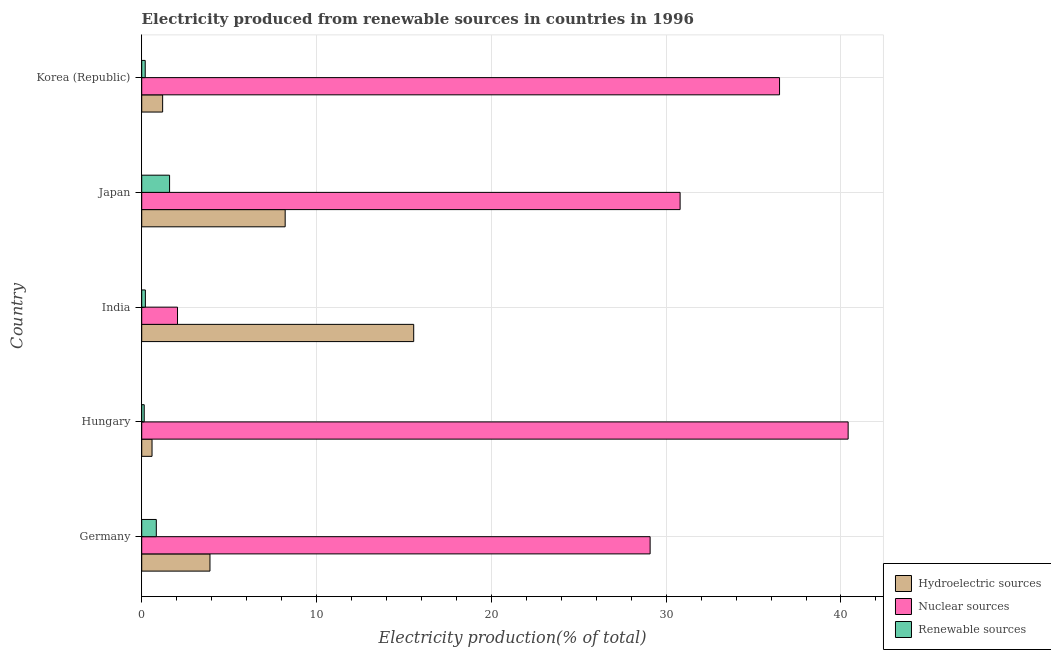How many different coloured bars are there?
Provide a succinct answer. 3. Are the number of bars per tick equal to the number of legend labels?
Keep it short and to the point. Yes. Are the number of bars on each tick of the Y-axis equal?
Your response must be concise. Yes. What is the label of the 1st group of bars from the top?
Provide a short and direct response. Korea (Republic). In how many cases, is the number of bars for a given country not equal to the number of legend labels?
Offer a terse response. 0. What is the percentage of electricity produced by renewable sources in Korea (Republic)?
Offer a very short reply. 0.2. Across all countries, what is the maximum percentage of electricity produced by hydroelectric sources?
Offer a terse response. 15.56. Across all countries, what is the minimum percentage of electricity produced by hydroelectric sources?
Make the answer very short. 0.59. In which country was the percentage of electricity produced by nuclear sources maximum?
Give a very brief answer. Hungary. What is the total percentage of electricity produced by nuclear sources in the graph?
Make the answer very short. 138.83. What is the difference between the percentage of electricity produced by hydroelectric sources in Germany and that in Hungary?
Keep it short and to the point. 3.31. What is the difference between the percentage of electricity produced by hydroelectric sources in Hungary and the percentage of electricity produced by renewable sources in Japan?
Provide a succinct answer. -1. What is the average percentage of electricity produced by renewable sources per country?
Your answer should be compact. 0.6. What is the difference between the percentage of electricity produced by hydroelectric sources and percentage of electricity produced by renewable sources in India?
Your response must be concise. 15.35. What is the ratio of the percentage of electricity produced by hydroelectric sources in Hungary to that in India?
Make the answer very short. 0.04. What is the difference between the highest and the second highest percentage of electricity produced by hydroelectric sources?
Make the answer very short. 7.35. What is the difference between the highest and the lowest percentage of electricity produced by hydroelectric sources?
Provide a short and direct response. 14.97. In how many countries, is the percentage of electricity produced by renewable sources greater than the average percentage of electricity produced by renewable sources taken over all countries?
Your answer should be compact. 2. What does the 2nd bar from the top in Germany represents?
Make the answer very short. Nuclear sources. What does the 3rd bar from the bottom in Korea (Republic) represents?
Provide a short and direct response. Renewable sources. Is it the case that in every country, the sum of the percentage of electricity produced by hydroelectric sources and percentage of electricity produced by nuclear sources is greater than the percentage of electricity produced by renewable sources?
Your answer should be very brief. Yes. How many bars are there?
Ensure brevity in your answer.  15. Does the graph contain any zero values?
Your answer should be very brief. No. How many legend labels are there?
Make the answer very short. 3. How are the legend labels stacked?
Your answer should be very brief. Vertical. What is the title of the graph?
Provide a succinct answer. Electricity produced from renewable sources in countries in 1996. Does "Injury" appear as one of the legend labels in the graph?
Your response must be concise. No. What is the label or title of the Y-axis?
Offer a terse response. Country. What is the Electricity production(% of total) of Hydroelectric sources in Germany?
Ensure brevity in your answer.  3.9. What is the Electricity production(% of total) in Nuclear sources in Germany?
Make the answer very short. 29.08. What is the Electricity production(% of total) in Renewable sources in Germany?
Your response must be concise. 0.83. What is the Electricity production(% of total) of Hydroelectric sources in Hungary?
Your response must be concise. 0.59. What is the Electricity production(% of total) in Nuclear sources in Hungary?
Provide a succinct answer. 40.41. What is the Electricity production(% of total) of Renewable sources in Hungary?
Provide a succinct answer. 0.14. What is the Electricity production(% of total) of Hydroelectric sources in India?
Offer a very short reply. 15.56. What is the Electricity production(% of total) in Nuclear sources in India?
Your answer should be very brief. 2.05. What is the Electricity production(% of total) of Renewable sources in India?
Your answer should be compact. 0.21. What is the Electricity production(% of total) of Hydroelectric sources in Japan?
Keep it short and to the point. 8.21. What is the Electricity production(% of total) in Nuclear sources in Japan?
Ensure brevity in your answer.  30.8. What is the Electricity production(% of total) of Renewable sources in Japan?
Keep it short and to the point. 1.59. What is the Electricity production(% of total) of Hydroelectric sources in Korea (Republic)?
Provide a succinct answer. 1.2. What is the Electricity production(% of total) of Nuclear sources in Korea (Republic)?
Keep it short and to the point. 36.49. What is the Electricity production(% of total) in Renewable sources in Korea (Republic)?
Make the answer very short. 0.2. Across all countries, what is the maximum Electricity production(% of total) in Hydroelectric sources?
Provide a short and direct response. 15.56. Across all countries, what is the maximum Electricity production(% of total) of Nuclear sources?
Offer a terse response. 40.41. Across all countries, what is the maximum Electricity production(% of total) of Renewable sources?
Offer a terse response. 1.59. Across all countries, what is the minimum Electricity production(% of total) in Hydroelectric sources?
Provide a succinct answer. 0.59. Across all countries, what is the minimum Electricity production(% of total) in Nuclear sources?
Your answer should be very brief. 2.05. Across all countries, what is the minimum Electricity production(% of total) in Renewable sources?
Provide a succinct answer. 0.14. What is the total Electricity production(% of total) of Hydroelectric sources in the graph?
Your answer should be very brief. 29.45. What is the total Electricity production(% of total) of Nuclear sources in the graph?
Give a very brief answer. 138.83. What is the total Electricity production(% of total) of Renewable sources in the graph?
Your answer should be very brief. 2.98. What is the difference between the Electricity production(% of total) in Hydroelectric sources in Germany and that in Hungary?
Offer a very short reply. 3.31. What is the difference between the Electricity production(% of total) in Nuclear sources in Germany and that in Hungary?
Offer a terse response. -11.33. What is the difference between the Electricity production(% of total) in Renewable sources in Germany and that in Hungary?
Make the answer very short. 0.69. What is the difference between the Electricity production(% of total) of Hydroelectric sources in Germany and that in India?
Keep it short and to the point. -11.65. What is the difference between the Electricity production(% of total) of Nuclear sources in Germany and that in India?
Your answer should be compact. 27.04. What is the difference between the Electricity production(% of total) of Renewable sources in Germany and that in India?
Your answer should be compact. 0.63. What is the difference between the Electricity production(% of total) of Hydroelectric sources in Germany and that in Japan?
Make the answer very short. -4.3. What is the difference between the Electricity production(% of total) of Nuclear sources in Germany and that in Japan?
Offer a very short reply. -1.72. What is the difference between the Electricity production(% of total) of Renewable sources in Germany and that in Japan?
Give a very brief answer. -0.76. What is the difference between the Electricity production(% of total) of Hydroelectric sources in Germany and that in Korea (Republic)?
Provide a succinct answer. 2.71. What is the difference between the Electricity production(% of total) of Nuclear sources in Germany and that in Korea (Republic)?
Give a very brief answer. -7.4. What is the difference between the Electricity production(% of total) of Renewable sources in Germany and that in Korea (Republic)?
Provide a short and direct response. 0.63. What is the difference between the Electricity production(% of total) in Hydroelectric sources in Hungary and that in India?
Give a very brief answer. -14.97. What is the difference between the Electricity production(% of total) in Nuclear sources in Hungary and that in India?
Offer a terse response. 38.36. What is the difference between the Electricity production(% of total) in Renewable sources in Hungary and that in India?
Give a very brief answer. -0.07. What is the difference between the Electricity production(% of total) of Hydroelectric sources in Hungary and that in Japan?
Provide a succinct answer. -7.62. What is the difference between the Electricity production(% of total) in Nuclear sources in Hungary and that in Japan?
Make the answer very short. 9.61. What is the difference between the Electricity production(% of total) of Renewable sources in Hungary and that in Japan?
Give a very brief answer. -1.45. What is the difference between the Electricity production(% of total) in Hydroelectric sources in Hungary and that in Korea (Republic)?
Give a very brief answer. -0.61. What is the difference between the Electricity production(% of total) of Nuclear sources in Hungary and that in Korea (Republic)?
Your answer should be compact. 3.92. What is the difference between the Electricity production(% of total) of Renewable sources in Hungary and that in Korea (Republic)?
Offer a very short reply. -0.06. What is the difference between the Electricity production(% of total) in Hydroelectric sources in India and that in Japan?
Offer a terse response. 7.35. What is the difference between the Electricity production(% of total) in Nuclear sources in India and that in Japan?
Ensure brevity in your answer.  -28.75. What is the difference between the Electricity production(% of total) of Renewable sources in India and that in Japan?
Your response must be concise. -1.38. What is the difference between the Electricity production(% of total) in Hydroelectric sources in India and that in Korea (Republic)?
Your answer should be very brief. 14.36. What is the difference between the Electricity production(% of total) in Nuclear sources in India and that in Korea (Republic)?
Give a very brief answer. -34.44. What is the difference between the Electricity production(% of total) of Renewable sources in India and that in Korea (Republic)?
Provide a short and direct response. 0.01. What is the difference between the Electricity production(% of total) of Hydroelectric sources in Japan and that in Korea (Republic)?
Offer a very short reply. 7.01. What is the difference between the Electricity production(% of total) of Nuclear sources in Japan and that in Korea (Republic)?
Your answer should be compact. -5.69. What is the difference between the Electricity production(% of total) in Renewable sources in Japan and that in Korea (Republic)?
Your response must be concise. 1.39. What is the difference between the Electricity production(% of total) in Hydroelectric sources in Germany and the Electricity production(% of total) in Nuclear sources in Hungary?
Offer a very short reply. -36.51. What is the difference between the Electricity production(% of total) of Hydroelectric sources in Germany and the Electricity production(% of total) of Renewable sources in Hungary?
Offer a very short reply. 3.76. What is the difference between the Electricity production(% of total) in Nuclear sources in Germany and the Electricity production(% of total) in Renewable sources in Hungary?
Provide a succinct answer. 28.94. What is the difference between the Electricity production(% of total) of Hydroelectric sources in Germany and the Electricity production(% of total) of Nuclear sources in India?
Provide a short and direct response. 1.86. What is the difference between the Electricity production(% of total) in Hydroelectric sources in Germany and the Electricity production(% of total) in Renewable sources in India?
Provide a short and direct response. 3.7. What is the difference between the Electricity production(% of total) in Nuclear sources in Germany and the Electricity production(% of total) in Renewable sources in India?
Make the answer very short. 28.87. What is the difference between the Electricity production(% of total) in Hydroelectric sources in Germany and the Electricity production(% of total) in Nuclear sources in Japan?
Offer a very short reply. -26.89. What is the difference between the Electricity production(% of total) in Hydroelectric sources in Germany and the Electricity production(% of total) in Renewable sources in Japan?
Your answer should be very brief. 2.31. What is the difference between the Electricity production(% of total) in Nuclear sources in Germany and the Electricity production(% of total) in Renewable sources in Japan?
Give a very brief answer. 27.49. What is the difference between the Electricity production(% of total) of Hydroelectric sources in Germany and the Electricity production(% of total) of Nuclear sources in Korea (Republic)?
Your answer should be compact. -32.58. What is the difference between the Electricity production(% of total) in Hydroelectric sources in Germany and the Electricity production(% of total) in Renewable sources in Korea (Republic)?
Offer a terse response. 3.7. What is the difference between the Electricity production(% of total) in Nuclear sources in Germany and the Electricity production(% of total) in Renewable sources in Korea (Republic)?
Offer a very short reply. 28.88. What is the difference between the Electricity production(% of total) of Hydroelectric sources in Hungary and the Electricity production(% of total) of Nuclear sources in India?
Keep it short and to the point. -1.46. What is the difference between the Electricity production(% of total) in Hydroelectric sources in Hungary and the Electricity production(% of total) in Renewable sources in India?
Your answer should be very brief. 0.38. What is the difference between the Electricity production(% of total) of Nuclear sources in Hungary and the Electricity production(% of total) of Renewable sources in India?
Ensure brevity in your answer.  40.2. What is the difference between the Electricity production(% of total) of Hydroelectric sources in Hungary and the Electricity production(% of total) of Nuclear sources in Japan?
Offer a very short reply. -30.21. What is the difference between the Electricity production(% of total) of Hydroelectric sources in Hungary and the Electricity production(% of total) of Renewable sources in Japan?
Make the answer very short. -1. What is the difference between the Electricity production(% of total) in Nuclear sources in Hungary and the Electricity production(% of total) in Renewable sources in Japan?
Your response must be concise. 38.82. What is the difference between the Electricity production(% of total) in Hydroelectric sources in Hungary and the Electricity production(% of total) in Nuclear sources in Korea (Republic)?
Make the answer very short. -35.9. What is the difference between the Electricity production(% of total) in Hydroelectric sources in Hungary and the Electricity production(% of total) in Renewable sources in Korea (Republic)?
Keep it short and to the point. 0.39. What is the difference between the Electricity production(% of total) of Nuclear sources in Hungary and the Electricity production(% of total) of Renewable sources in Korea (Republic)?
Give a very brief answer. 40.21. What is the difference between the Electricity production(% of total) in Hydroelectric sources in India and the Electricity production(% of total) in Nuclear sources in Japan?
Provide a short and direct response. -15.24. What is the difference between the Electricity production(% of total) in Hydroelectric sources in India and the Electricity production(% of total) in Renewable sources in Japan?
Provide a short and direct response. 13.97. What is the difference between the Electricity production(% of total) of Nuclear sources in India and the Electricity production(% of total) of Renewable sources in Japan?
Your answer should be compact. 0.45. What is the difference between the Electricity production(% of total) of Hydroelectric sources in India and the Electricity production(% of total) of Nuclear sources in Korea (Republic)?
Keep it short and to the point. -20.93. What is the difference between the Electricity production(% of total) of Hydroelectric sources in India and the Electricity production(% of total) of Renewable sources in Korea (Republic)?
Your response must be concise. 15.36. What is the difference between the Electricity production(% of total) of Nuclear sources in India and the Electricity production(% of total) of Renewable sources in Korea (Republic)?
Keep it short and to the point. 1.85. What is the difference between the Electricity production(% of total) of Hydroelectric sources in Japan and the Electricity production(% of total) of Nuclear sources in Korea (Republic)?
Provide a succinct answer. -28.28. What is the difference between the Electricity production(% of total) in Hydroelectric sources in Japan and the Electricity production(% of total) in Renewable sources in Korea (Republic)?
Make the answer very short. 8.01. What is the difference between the Electricity production(% of total) in Nuclear sources in Japan and the Electricity production(% of total) in Renewable sources in Korea (Republic)?
Offer a terse response. 30.6. What is the average Electricity production(% of total) in Hydroelectric sources per country?
Ensure brevity in your answer.  5.89. What is the average Electricity production(% of total) of Nuclear sources per country?
Give a very brief answer. 27.77. What is the average Electricity production(% of total) in Renewable sources per country?
Ensure brevity in your answer.  0.6. What is the difference between the Electricity production(% of total) in Hydroelectric sources and Electricity production(% of total) in Nuclear sources in Germany?
Your answer should be very brief. -25.18. What is the difference between the Electricity production(% of total) of Hydroelectric sources and Electricity production(% of total) of Renewable sources in Germany?
Provide a short and direct response. 3.07. What is the difference between the Electricity production(% of total) of Nuclear sources and Electricity production(% of total) of Renewable sources in Germany?
Ensure brevity in your answer.  28.25. What is the difference between the Electricity production(% of total) in Hydroelectric sources and Electricity production(% of total) in Nuclear sources in Hungary?
Ensure brevity in your answer.  -39.82. What is the difference between the Electricity production(% of total) of Hydroelectric sources and Electricity production(% of total) of Renewable sources in Hungary?
Offer a very short reply. 0.45. What is the difference between the Electricity production(% of total) in Nuclear sources and Electricity production(% of total) in Renewable sources in Hungary?
Provide a short and direct response. 40.27. What is the difference between the Electricity production(% of total) in Hydroelectric sources and Electricity production(% of total) in Nuclear sources in India?
Your answer should be very brief. 13.51. What is the difference between the Electricity production(% of total) of Hydroelectric sources and Electricity production(% of total) of Renewable sources in India?
Make the answer very short. 15.35. What is the difference between the Electricity production(% of total) of Nuclear sources and Electricity production(% of total) of Renewable sources in India?
Offer a terse response. 1.84. What is the difference between the Electricity production(% of total) in Hydroelectric sources and Electricity production(% of total) in Nuclear sources in Japan?
Your response must be concise. -22.59. What is the difference between the Electricity production(% of total) in Hydroelectric sources and Electricity production(% of total) in Renewable sources in Japan?
Give a very brief answer. 6.61. What is the difference between the Electricity production(% of total) in Nuclear sources and Electricity production(% of total) in Renewable sources in Japan?
Your response must be concise. 29.2. What is the difference between the Electricity production(% of total) in Hydroelectric sources and Electricity production(% of total) in Nuclear sources in Korea (Republic)?
Ensure brevity in your answer.  -35.29. What is the difference between the Electricity production(% of total) of Hydroelectric sources and Electricity production(% of total) of Renewable sources in Korea (Republic)?
Offer a very short reply. 1. What is the difference between the Electricity production(% of total) of Nuclear sources and Electricity production(% of total) of Renewable sources in Korea (Republic)?
Offer a very short reply. 36.29. What is the ratio of the Electricity production(% of total) of Hydroelectric sources in Germany to that in Hungary?
Offer a very short reply. 6.62. What is the ratio of the Electricity production(% of total) of Nuclear sources in Germany to that in Hungary?
Your answer should be very brief. 0.72. What is the ratio of the Electricity production(% of total) of Renewable sources in Germany to that in Hungary?
Offer a very short reply. 5.86. What is the ratio of the Electricity production(% of total) in Hydroelectric sources in Germany to that in India?
Make the answer very short. 0.25. What is the ratio of the Electricity production(% of total) in Nuclear sources in Germany to that in India?
Ensure brevity in your answer.  14.2. What is the ratio of the Electricity production(% of total) of Renewable sources in Germany to that in India?
Your response must be concise. 4. What is the ratio of the Electricity production(% of total) in Hydroelectric sources in Germany to that in Japan?
Keep it short and to the point. 0.48. What is the ratio of the Electricity production(% of total) of Nuclear sources in Germany to that in Japan?
Keep it short and to the point. 0.94. What is the ratio of the Electricity production(% of total) of Renewable sources in Germany to that in Japan?
Provide a short and direct response. 0.52. What is the ratio of the Electricity production(% of total) of Hydroelectric sources in Germany to that in Korea (Republic)?
Offer a terse response. 3.26. What is the ratio of the Electricity production(% of total) of Nuclear sources in Germany to that in Korea (Republic)?
Make the answer very short. 0.8. What is the ratio of the Electricity production(% of total) in Renewable sources in Germany to that in Korea (Republic)?
Make the answer very short. 4.17. What is the ratio of the Electricity production(% of total) in Hydroelectric sources in Hungary to that in India?
Give a very brief answer. 0.04. What is the ratio of the Electricity production(% of total) in Nuclear sources in Hungary to that in India?
Your answer should be compact. 19.74. What is the ratio of the Electricity production(% of total) in Renewable sources in Hungary to that in India?
Make the answer very short. 0.68. What is the ratio of the Electricity production(% of total) in Hydroelectric sources in Hungary to that in Japan?
Provide a short and direct response. 0.07. What is the ratio of the Electricity production(% of total) in Nuclear sources in Hungary to that in Japan?
Give a very brief answer. 1.31. What is the ratio of the Electricity production(% of total) of Renewable sources in Hungary to that in Japan?
Make the answer very short. 0.09. What is the ratio of the Electricity production(% of total) in Hydroelectric sources in Hungary to that in Korea (Republic)?
Give a very brief answer. 0.49. What is the ratio of the Electricity production(% of total) in Nuclear sources in Hungary to that in Korea (Republic)?
Provide a short and direct response. 1.11. What is the ratio of the Electricity production(% of total) in Renewable sources in Hungary to that in Korea (Republic)?
Provide a short and direct response. 0.71. What is the ratio of the Electricity production(% of total) in Hydroelectric sources in India to that in Japan?
Keep it short and to the point. 1.9. What is the ratio of the Electricity production(% of total) of Nuclear sources in India to that in Japan?
Give a very brief answer. 0.07. What is the ratio of the Electricity production(% of total) in Renewable sources in India to that in Japan?
Keep it short and to the point. 0.13. What is the ratio of the Electricity production(% of total) in Hydroelectric sources in India to that in Korea (Republic)?
Provide a short and direct response. 13. What is the ratio of the Electricity production(% of total) of Nuclear sources in India to that in Korea (Republic)?
Provide a short and direct response. 0.06. What is the ratio of the Electricity production(% of total) of Renewable sources in India to that in Korea (Republic)?
Offer a very short reply. 1.04. What is the ratio of the Electricity production(% of total) in Hydroelectric sources in Japan to that in Korea (Republic)?
Your answer should be compact. 6.86. What is the ratio of the Electricity production(% of total) in Nuclear sources in Japan to that in Korea (Republic)?
Offer a very short reply. 0.84. What is the ratio of the Electricity production(% of total) in Renewable sources in Japan to that in Korea (Republic)?
Provide a succinct answer. 7.95. What is the difference between the highest and the second highest Electricity production(% of total) of Hydroelectric sources?
Offer a terse response. 7.35. What is the difference between the highest and the second highest Electricity production(% of total) of Nuclear sources?
Your answer should be very brief. 3.92. What is the difference between the highest and the second highest Electricity production(% of total) of Renewable sources?
Ensure brevity in your answer.  0.76. What is the difference between the highest and the lowest Electricity production(% of total) of Hydroelectric sources?
Make the answer very short. 14.97. What is the difference between the highest and the lowest Electricity production(% of total) of Nuclear sources?
Offer a very short reply. 38.36. What is the difference between the highest and the lowest Electricity production(% of total) of Renewable sources?
Ensure brevity in your answer.  1.45. 